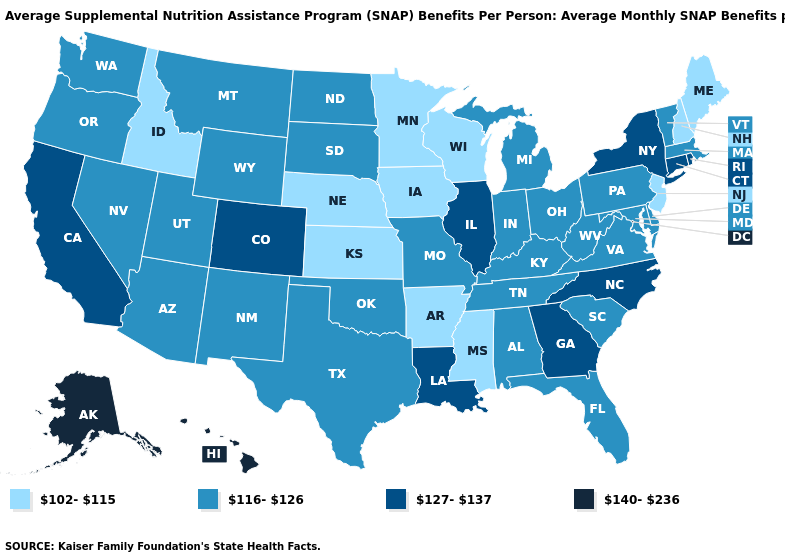Name the states that have a value in the range 102-115?
Concise answer only. Arkansas, Idaho, Iowa, Kansas, Maine, Minnesota, Mississippi, Nebraska, New Hampshire, New Jersey, Wisconsin. Does Alaska have the highest value in the USA?
Quick response, please. Yes. How many symbols are there in the legend?
Short answer required. 4. Among the states that border Virginia , which have the highest value?
Concise answer only. North Carolina. Among the states that border Massachusetts , does Vermont have the highest value?
Concise answer only. No. Name the states that have a value in the range 102-115?
Short answer required. Arkansas, Idaho, Iowa, Kansas, Maine, Minnesota, Mississippi, Nebraska, New Hampshire, New Jersey, Wisconsin. Does Georgia have the same value as Nebraska?
Write a very short answer. No. Is the legend a continuous bar?
Be succinct. No. Does Arkansas have the lowest value in the USA?
Quick response, please. Yes. Name the states that have a value in the range 127-137?
Be succinct. California, Colorado, Connecticut, Georgia, Illinois, Louisiana, New York, North Carolina, Rhode Island. What is the value of Nevada?
Write a very short answer. 116-126. What is the value of Maryland?
Write a very short answer. 116-126. Does Illinois have the highest value in the MidWest?
Answer briefly. Yes. Does Alaska have the lowest value in the West?
Short answer required. No. Among the states that border Vermont , which have the lowest value?
Give a very brief answer. New Hampshire. 